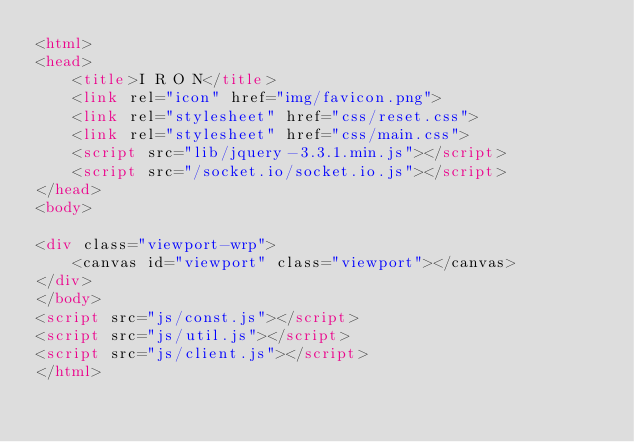<code> <loc_0><loc_0><loc_500><loc_500><_HTML_><html>
<head>
	<title>I R O N</title>
	<link rel="icon" href="img/favicon.png">
	<link rel="stylesheet" href="css/reset.css">
	<link rel="stylesheet" href="css/main.css">
	<script src="lib/jquery-3.3.1.min.js"></script>
	<script src="/socket.io/socket.io.js"></script>
</head>
<body>

<div class="viewport-wrp">
	<canvas id="viewport" class="viewport"></canvas>
</div>
</body>
<script src="js/const.js"></script>
<script src="js/util.js"></script>
<script src="js/client.js"></script>
</html></code> 